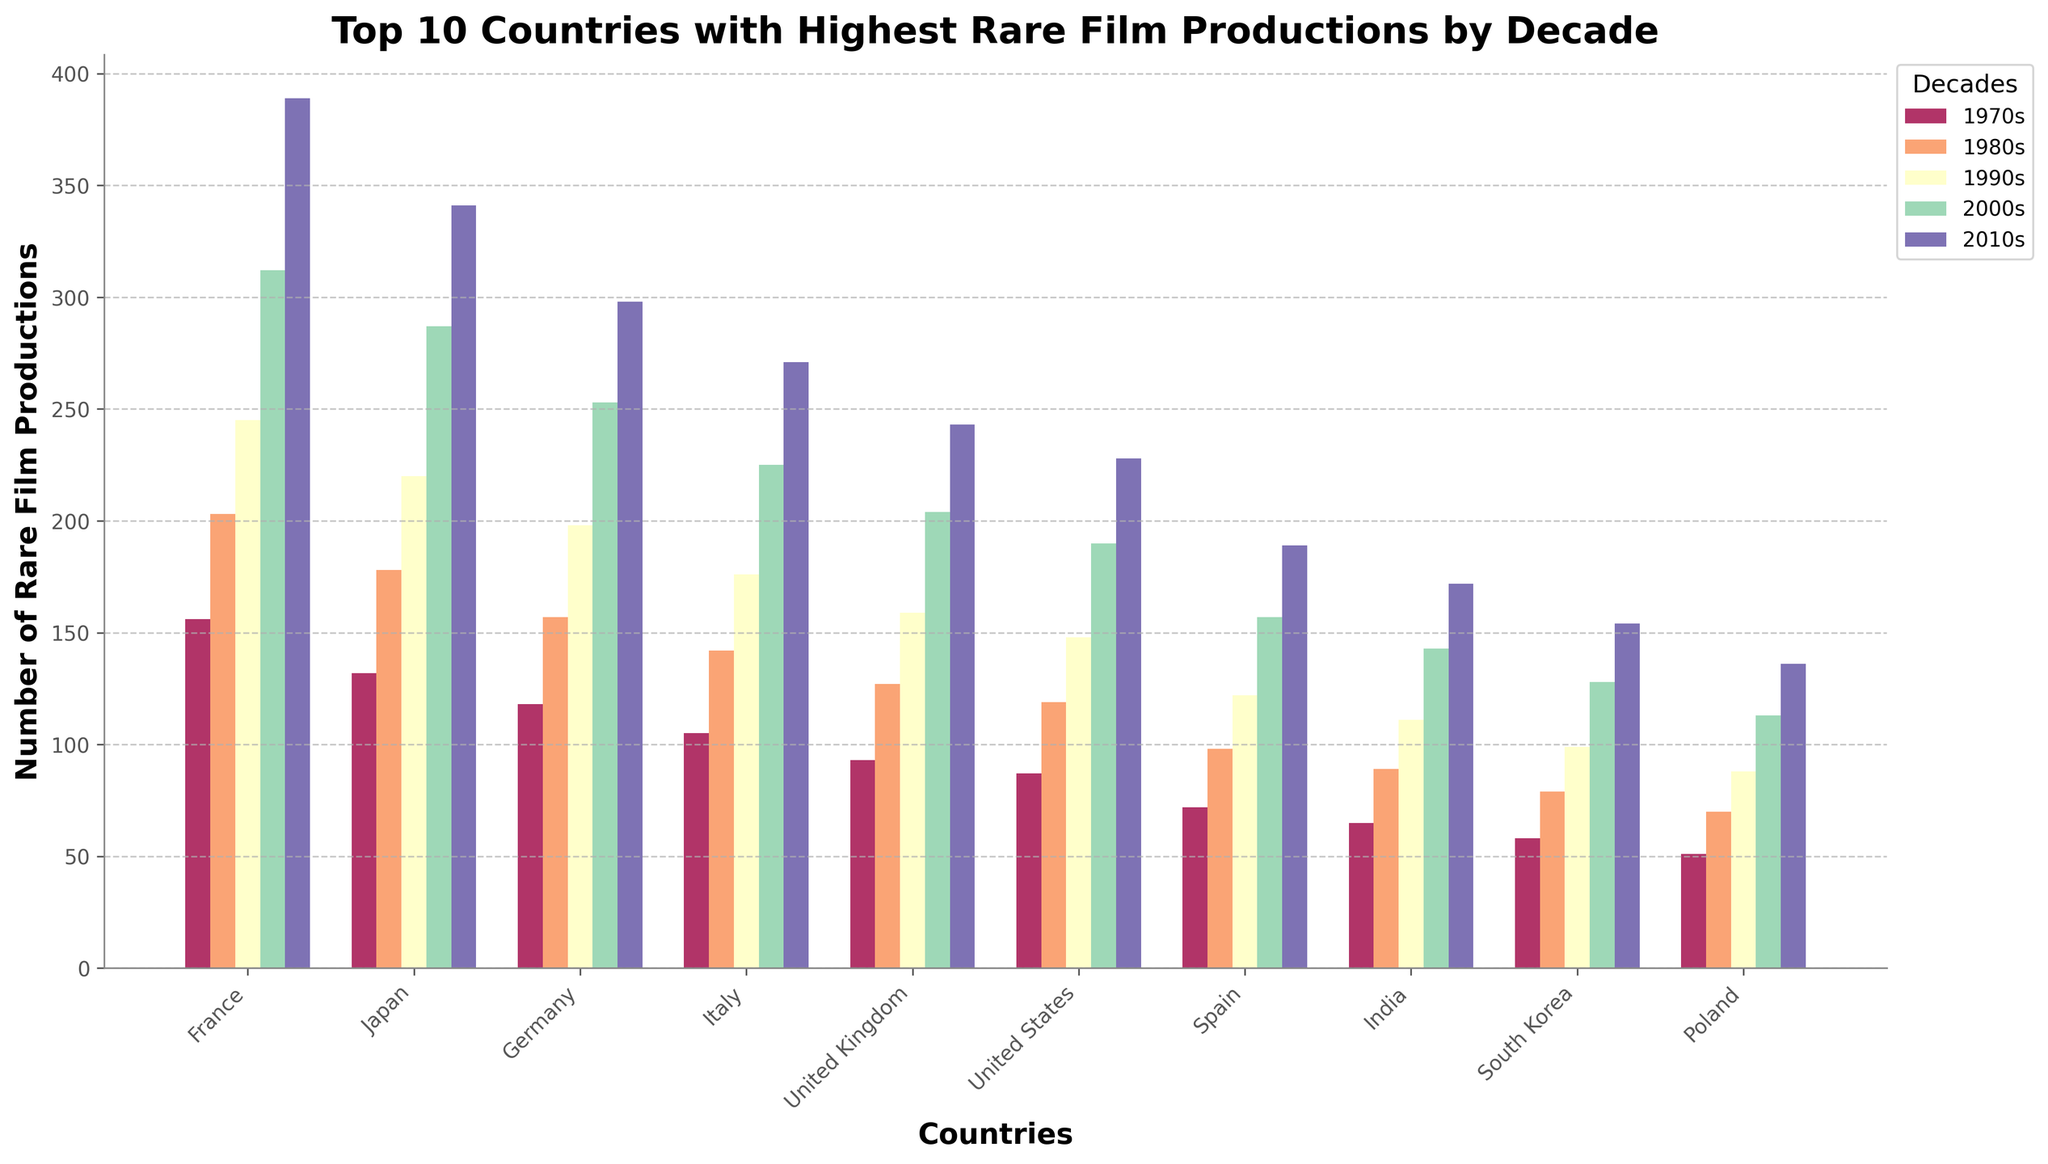What is the total number of rare film productions from France across all the decades? To find the total number of rare film productions in France, sum up the values for each decade: 156 (1970s) + 203 (1980s) + 245 (1990s) + 312 (2000s) + 389 (2010s), which equals 156 + 203 + 245 + 312 + 389 = 1305.
Answer: 1305 Which country had the highest number of rare film productions in the 2010s? To determine the country with the highest number of rare film productions in the 2010s, compare the heights of the bars for each country in the 2010s. France's bar is the tallest, representing 389 films, which is higher than any other country's production in the 2010s.
Answer: France How many more rare films did Germany produce in the 2000s compared to the 1970s? To find the difference in production, subtract the number of films produced in the 1970s from the number in the 2000s for Germany, which is 253 (2000s) - 118 (1970s). So, 253 - 118 = 135.
Answer: 135 What is the average number of rare film productions for Japan across the decades? To find the average, sum Japan's film production across the decades and divide by the number of decades. The sum is 132 (1970s) + 178 (1980s) + 220 (1990s) + 287 (2000s) + 341 (2010s) = 1158. Dividing by 5 decades gives 1158 / 5 = 231.6.
Answer: 231.6 Which country showed the largest increase in rare film productions from the 1980s to the 2010s? To find the largest increase, calculate the difference between the 1980s and 2010s for each country, then identify the largest value. France's increase is 389 - 203 = 186. Comparing the increments for all countries, France's increase (186) is the highest.
Answer: France Comparing Italy and the United Kingdom, which had more rare film productions in the 1990s, and by how much? Italy produced 176 films while the United Kingdom produced 159 films in the 1990s. Subtract the UK's production from Italy's to find the difference: 176 - 159 = 17.
Answer: Italy by 17 What is the combined number of rare film productions for the United States in the 1970s and 1980s? To find the combined number, add the film productions for the United States in the 1970s and 1980s: 87 (1970s) + 119 (1980s) = 206.
Answer: 206 Which decade shows the smallest number of rare film productions for South Korea? To determine the smallest production decade, compare the bar heights across the decades for South Korea. The production numbers are 58 (1970s), 79 (1980s), 99 (1990s), 128 (2000s), and 154 (2010s). The smallest value is 58 from the 1970s.
Answer: 1970s What visual trend can be observed in the number of rare film productions for all countries from the 1970s to the 2010s? Observing the bar heights across all countries and decades, a clear trend of increasing heights can be seen, indicating a general trend of increasing rare film productions over the decades.
Answer: Increase 